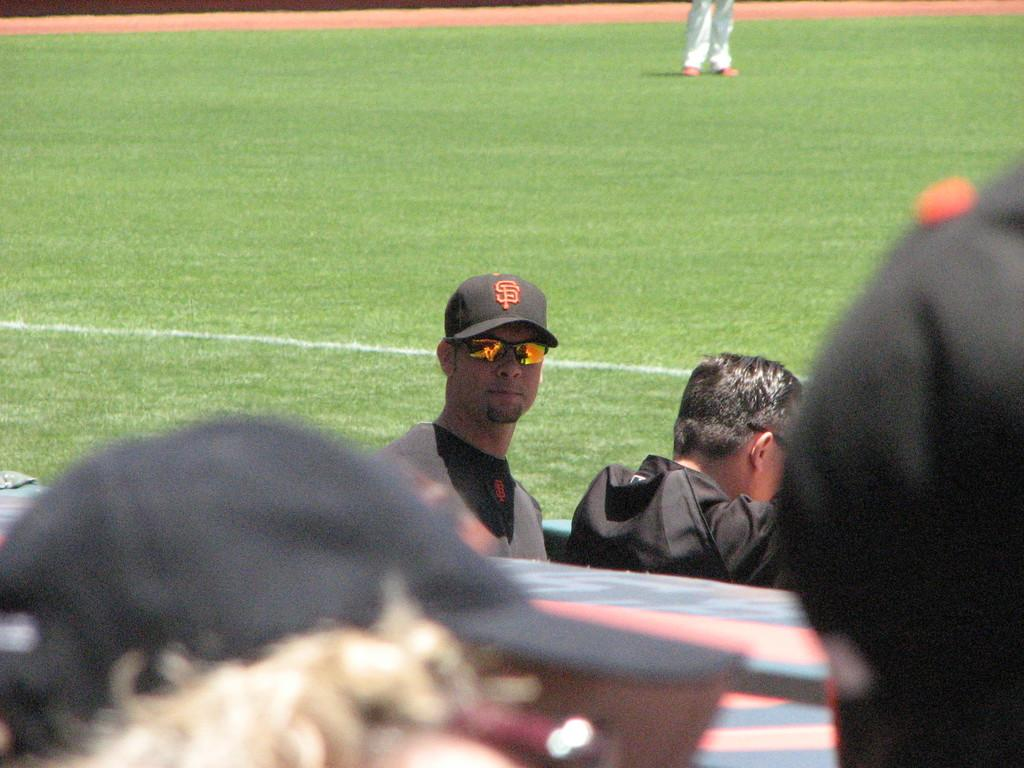Who is present in the image? There is a man in the image. What is the man doing in the image? The man is looking to his side. What type of clothing is the man wearing? The man is wearing a t-shirt, spectacles, and a cap. What is the ground like in the image? The ground is visible in the image. What type of lunchroom can be seen in the image? There is no lunchroom present in the image. What is the man trying to burn in the image? There is no indication of the man trying to burn anything in the image. 